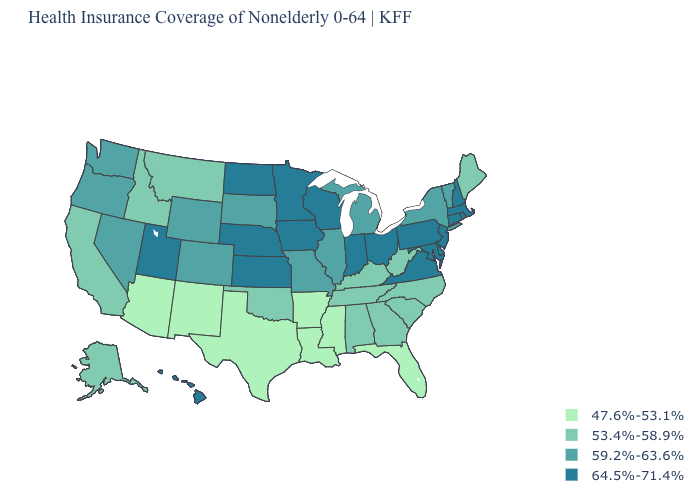How many symbols are there in the legend?
Short answer required. 4. What is the highest value in states that border Pennsylvania?
Be succinct. 64.5%-71.4%. What is the value of Delaware?
Write a very short answer. 64.5%-71.4%. Name the states that have a value in the range 59.2%-63.6%?
Quick response, please. Colorado, Illinois, Michigan, Missouri, Nevada, New York, Oregon, South Dakota, Vermont, Washington, Wyoming. Which states have the lowest value in the MidWest?
Short answer required. Illinois, Michigan, Missouri, South Dakota. Does Michigan have a higher value than Maryland?
Give a very brief answer. No. Does Idaho have the highest value in the USA?
Be succinct. No. What is the value of Florida?
Quick response, please. 47.6%-53.1%. How many symbols are there in the legend?
Give a very brief answer. 4. Does Nevada have the highest value in the USA?
Concise answer only. No. Does Maryland have a higher value than Arizona?
Concise answer only. Yes. Is the legend a continuous bar?
Keep it brief. No. What is the value of Oregon?
Short answer required. 59.2%-63.6%. Does Hawaii have the highest value in the West?
Write a very short answer. Yes. 